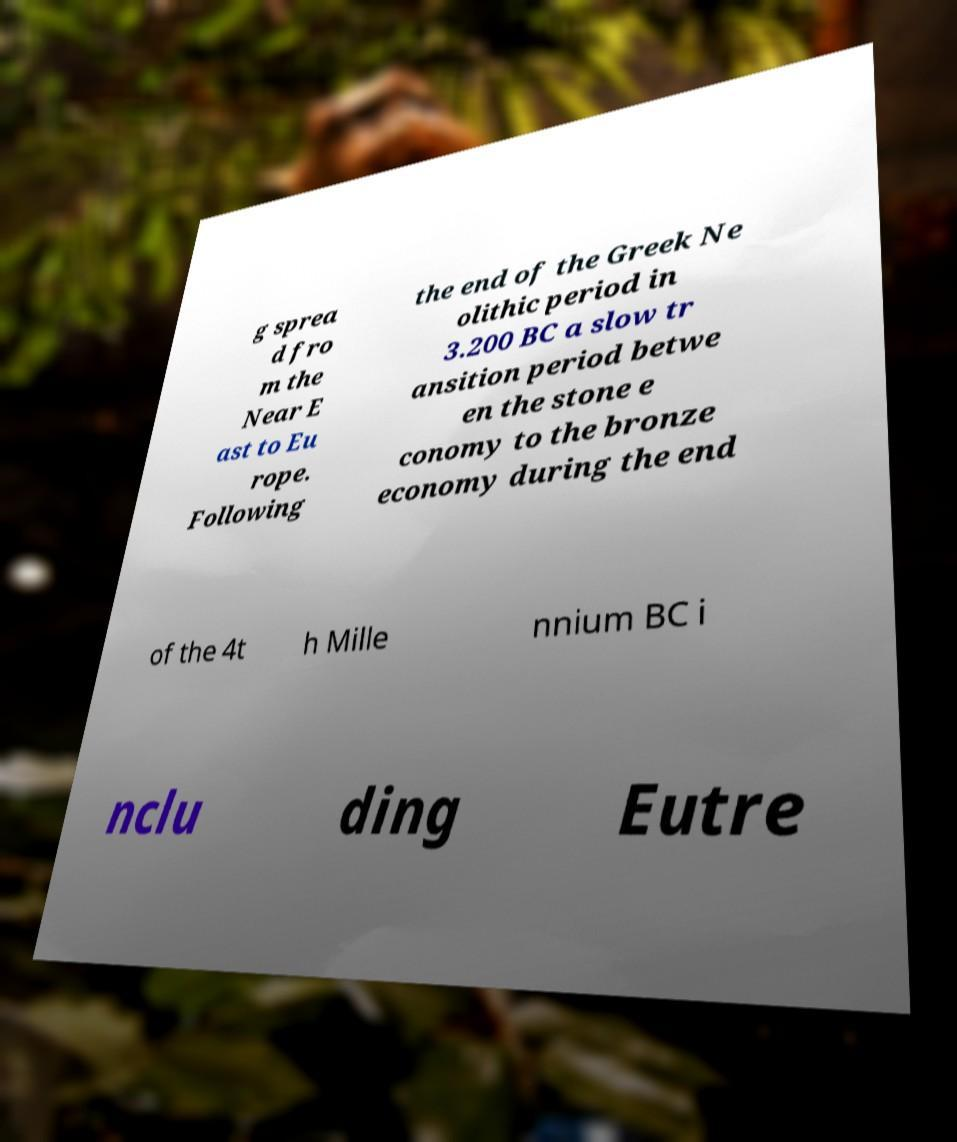Could you extract and type out the text from this image? g sprea d fro m the Near E ast to Eu rope. Following the end of the Greek Ne olithic period in 3.200 BC a slow tr ansition period betwe en the stone e conomy to the bronze economy during the end of the 4t h Mille nnium BC i nclu ding Eutre 